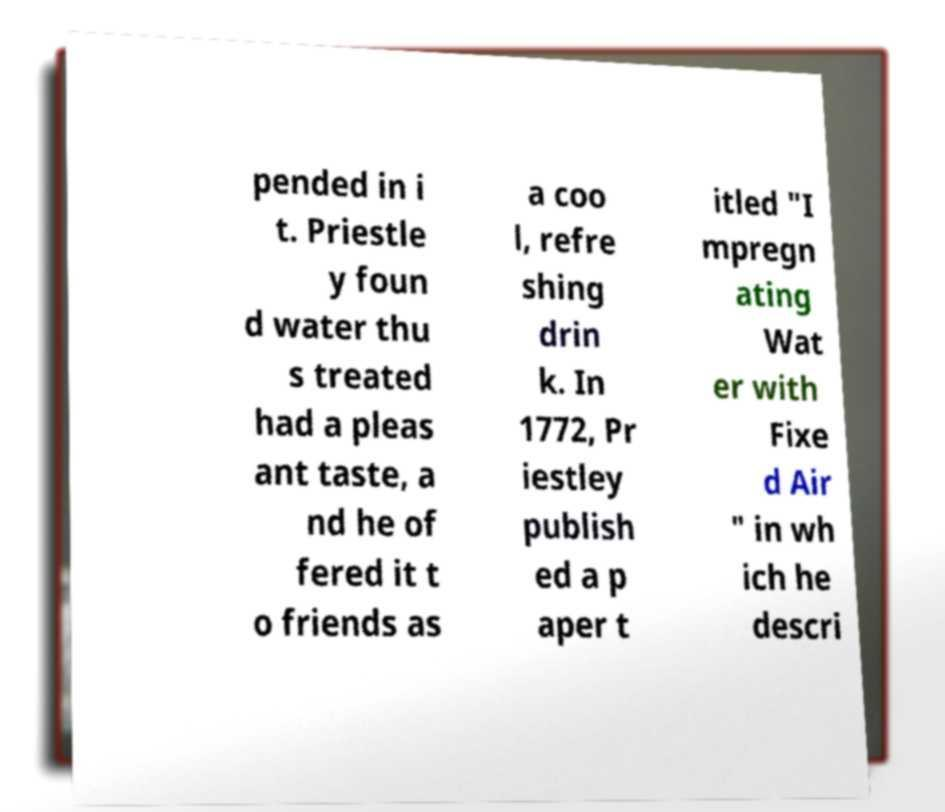Could you assist in decoding the text presented in this image and type it out clearly? pended in i t. Priestle y foun d water thu s treated had a pleas ant taste, a nd he of fered it t o friends as a coo l, refre shing drin k. In 1772, Pr iestley publish ed a p aper t itled "I mpregn ating Wat er with Fixe d Air " in wh ich he descri 